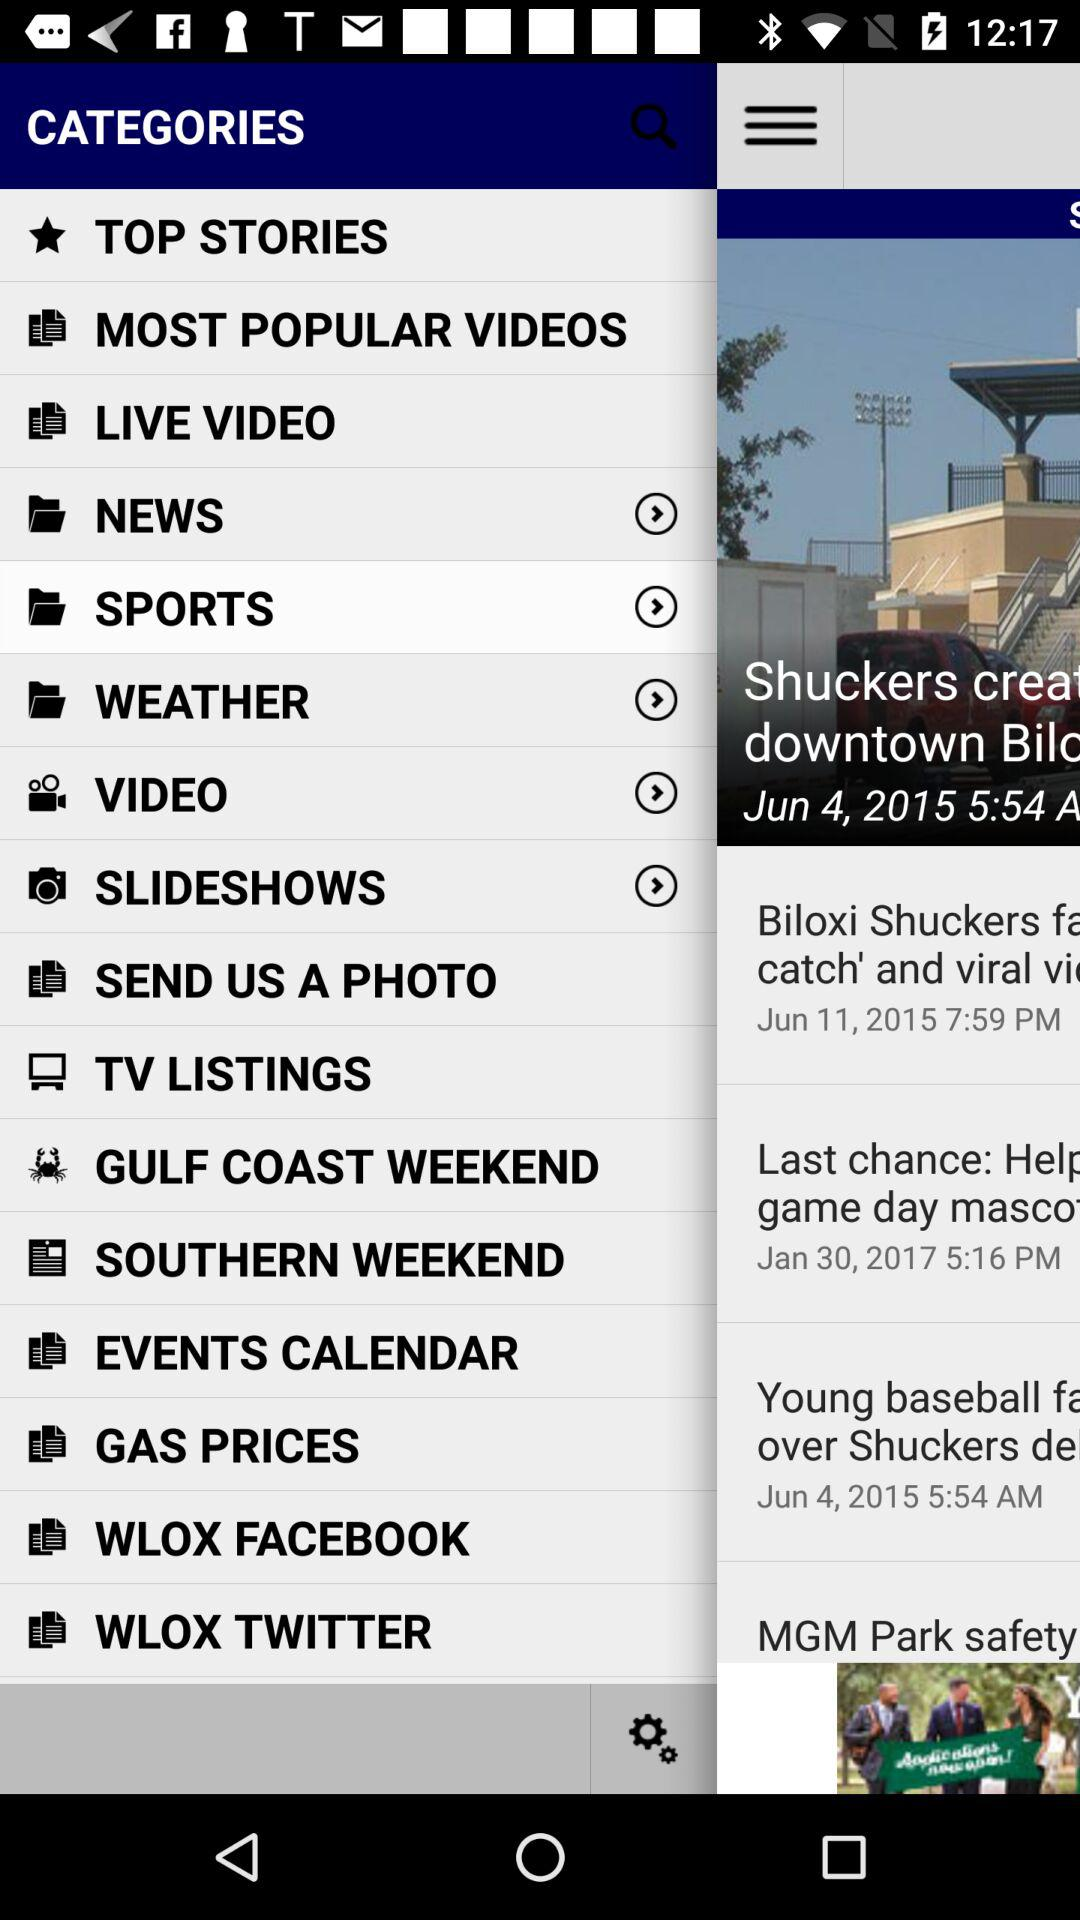Which option is selected? The selected option is "Sports". 